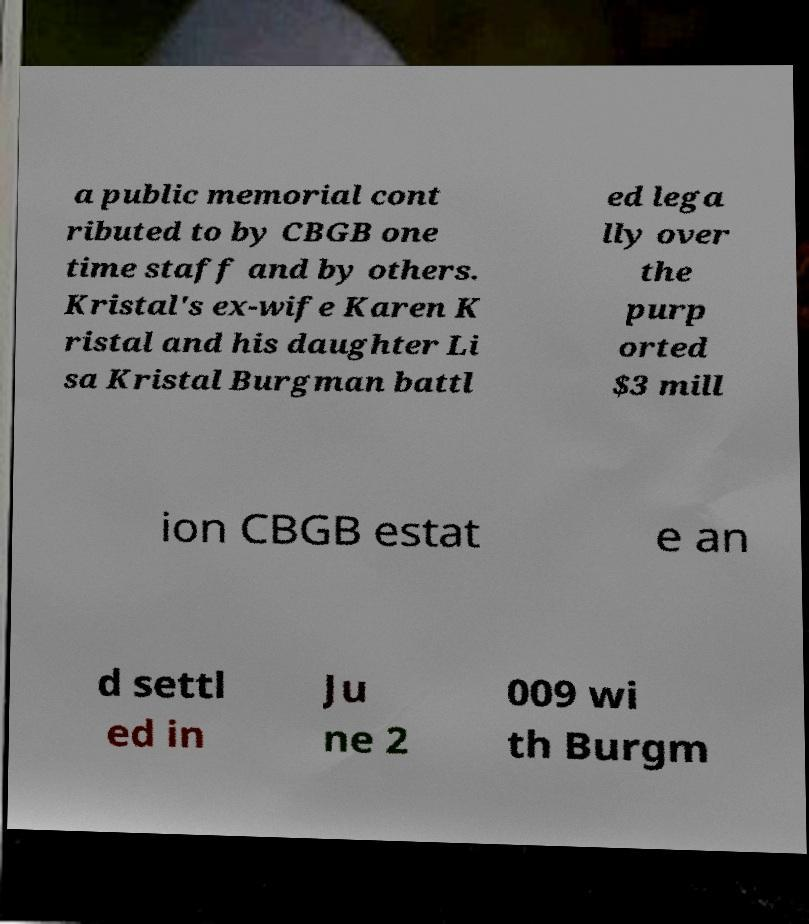There's text embedded in this image that I need extracted. Can you transcribe it verbatim? a public memorial cont ributed to by CBGB one time staff and by others. Kristal's ex-wife Karen K ristal and his daughter Li sa Kristal Burgman battl ed lega lly over the purp orted $3 mill ion CBGB estat e an d settl ed in Ju ne 2 009 wi th Burgm 